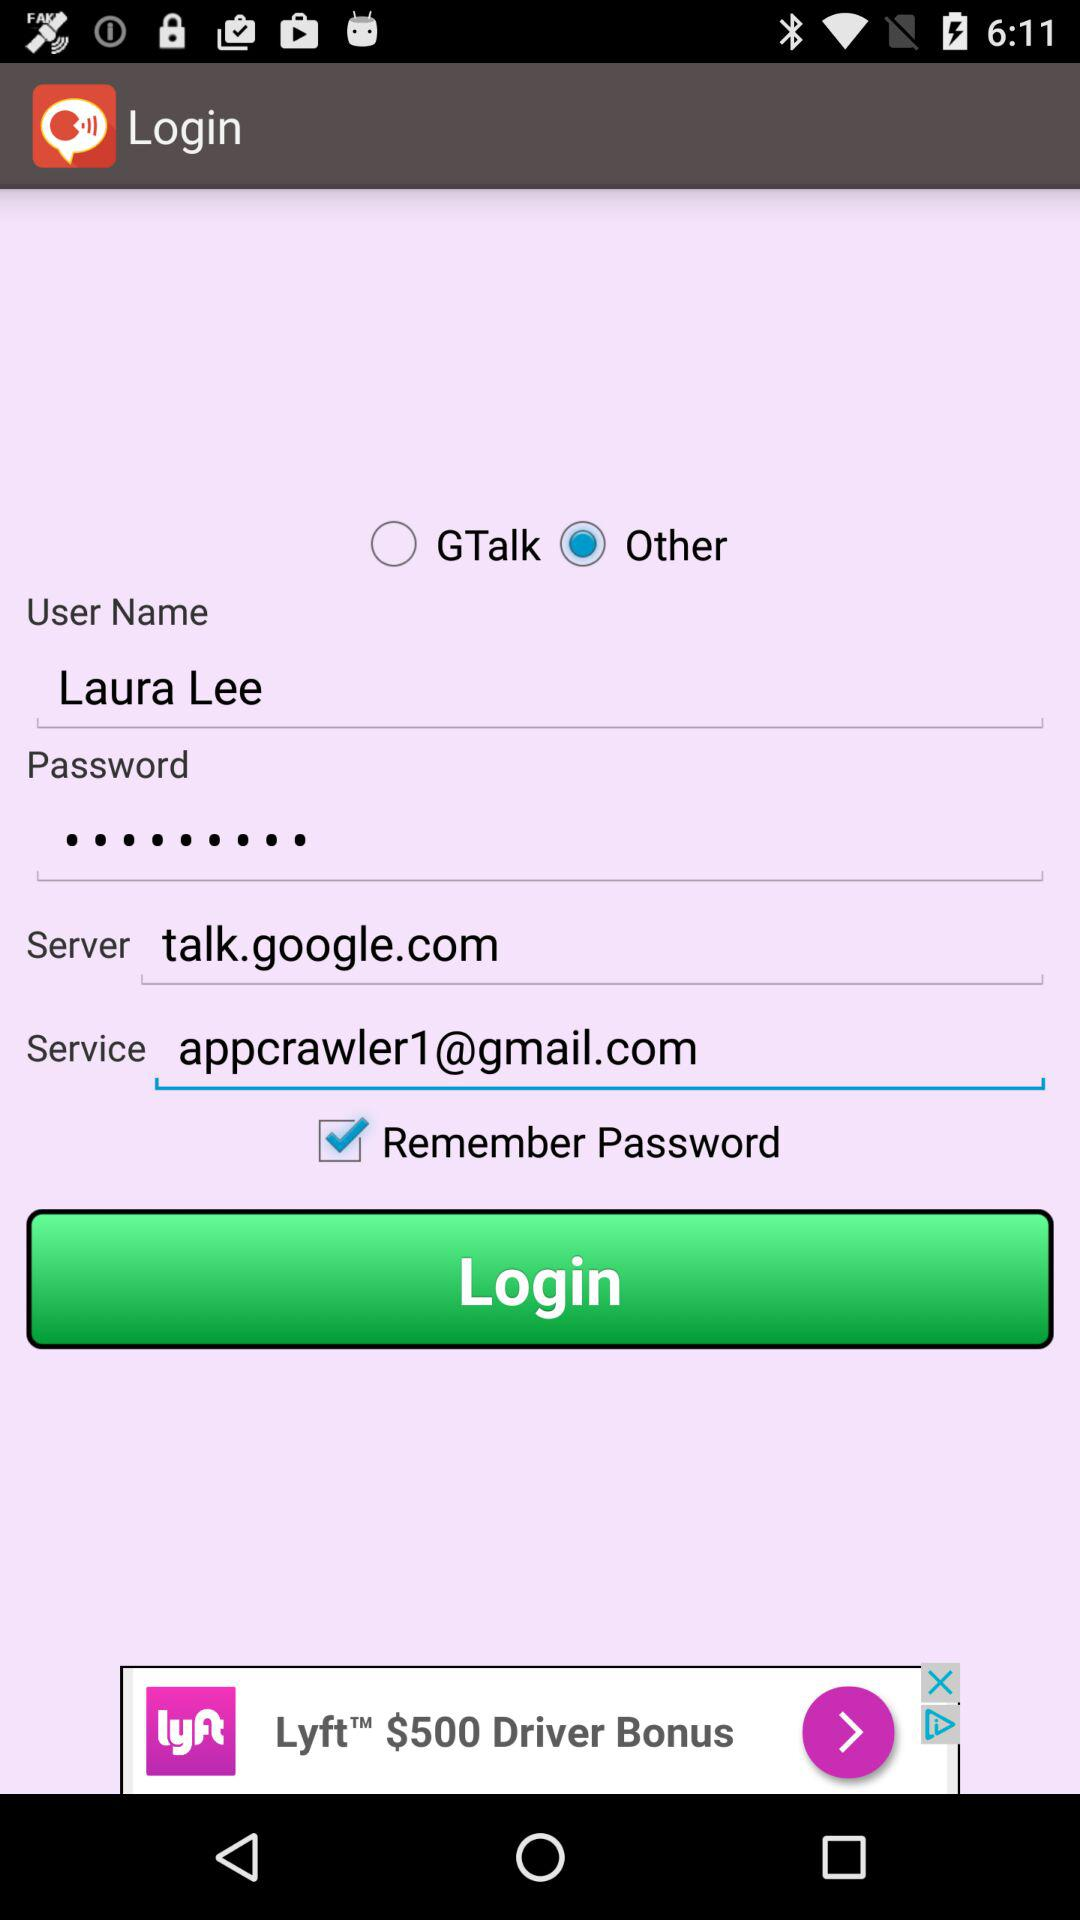What is the name of the application?
When the provided information is insufficient, respond with <no answer>. <no answer> 